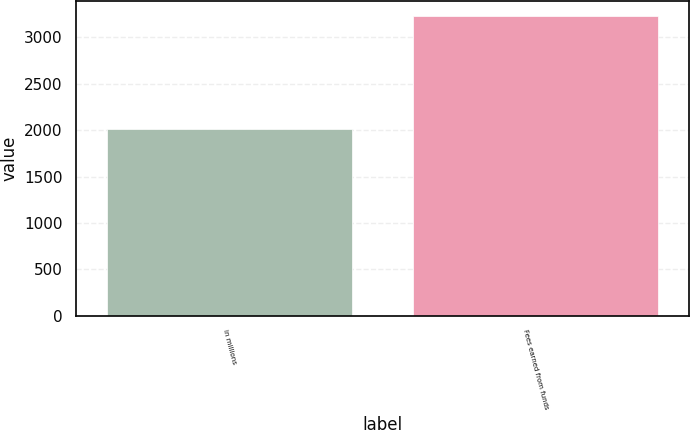Convert chart. <chart><loc_0><loc_0><loc_500><loc_500><bar_chart><fcel>in millions<fcel>Fees earned from funds<nl><fcel>2014<fcel>3232<nl></chart> 